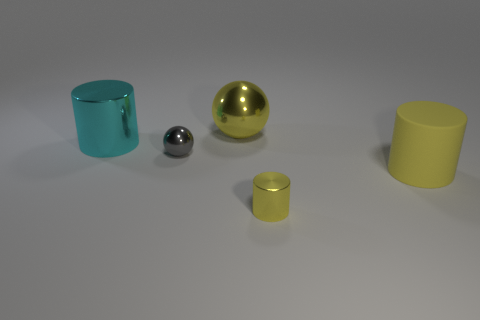Subtract all green cylinders. Subtract all blue balls. How many cylinders are left? 3 Add 1 big blue metal spheres. How many objects exist? 6 Subtract all cylinders. How many objects are left? 2 Add 5 small gray shiny spheres. How many small gray shiny spheres exist? 6 Subtract 0 cyan blocks. How many objects are left? 5 Subtract all cyan things. Subtract all large rubber things. How many objects are left? 3 Add 3 metallic cylinders. How many metallic cylinders are left? 5 